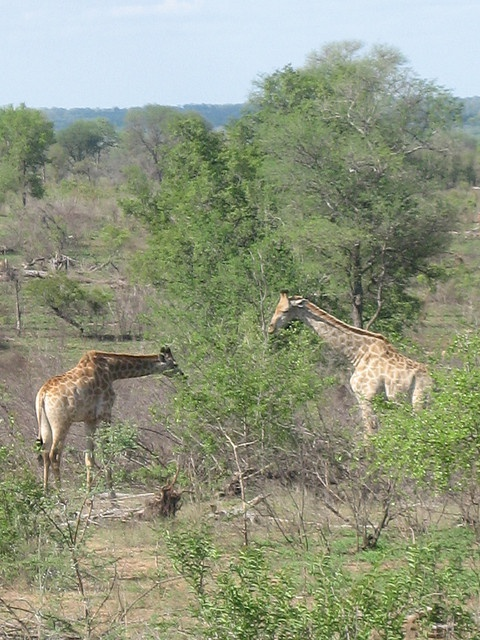Describe the objects in this image and their specific colors. I can see giraffe in lavender, tan, and gray tones and giraffe in lavender, gray, and darkgray tones in this image. 